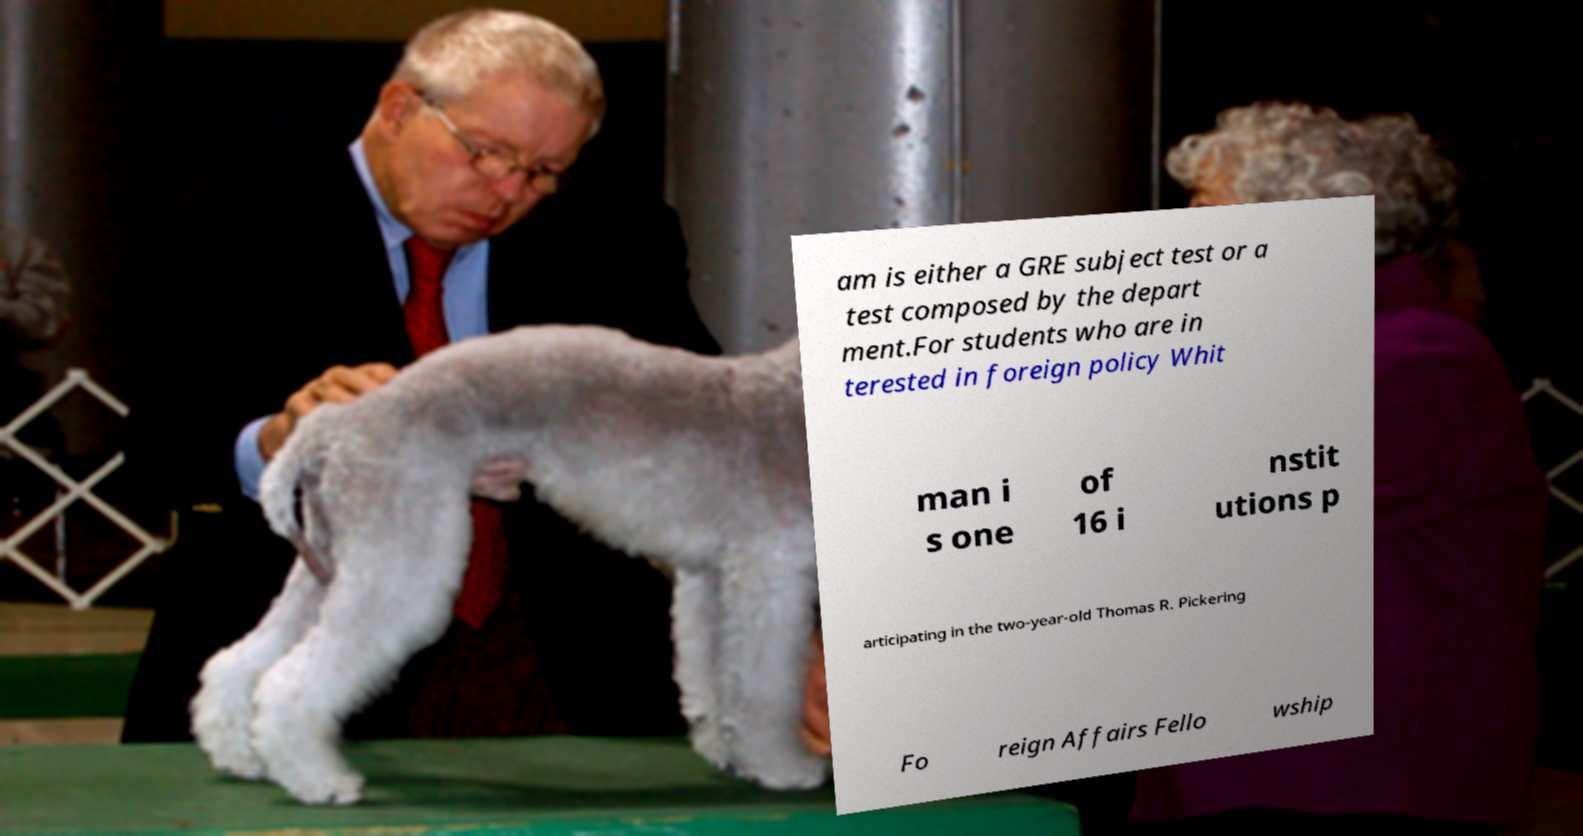Please read and relay the text visible in this image. What does it say? am is either a GRE subject test or a test composed by the depart ment.For students who are in terested in foreign policy Whit man i s one of 16 i nstit utions p articipating in the two-year-old Thomas R. Pickering Fo reign Affairs Fello wship 